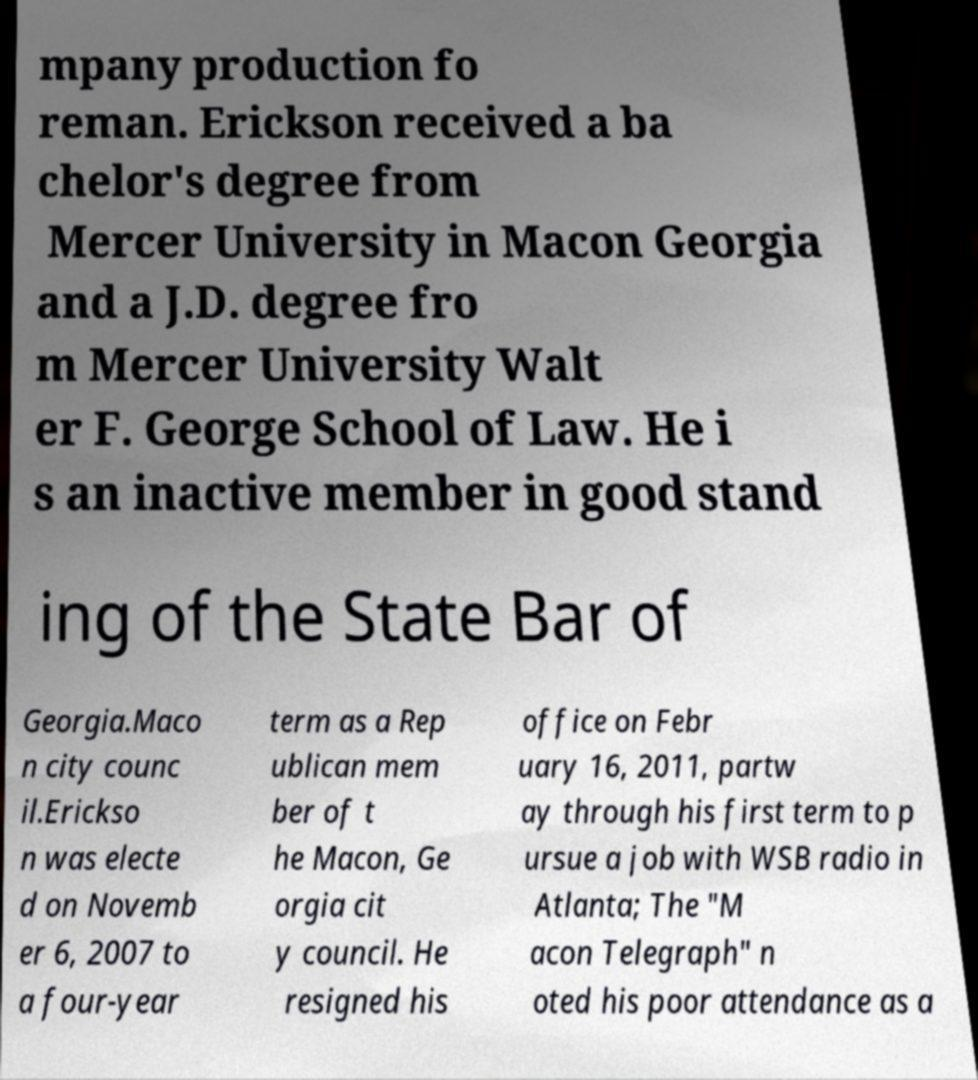Could you extract and type out the text from this image? mpany production fo reman. Erickson received a ba chelor's degree from Mercer University in Macon Georgia and a J.D. degree fro m Mercer University Walt er F. George School of Law. He i s an inactive member in good stand ing of the State Bar of Georgia.Maco n city counc il.Erickso n was electe d on Novemb er 6, 2007 to a four-year term as a Rep ublican mem ber of t he Macon, Ge orgia cit y council. He resigned his office on Febr uary 16, 2011, partw ay through his first term to p ursue a job with WSB radio in Atlanta; The "M acon Telegraph" n oted his poor attendance as a 